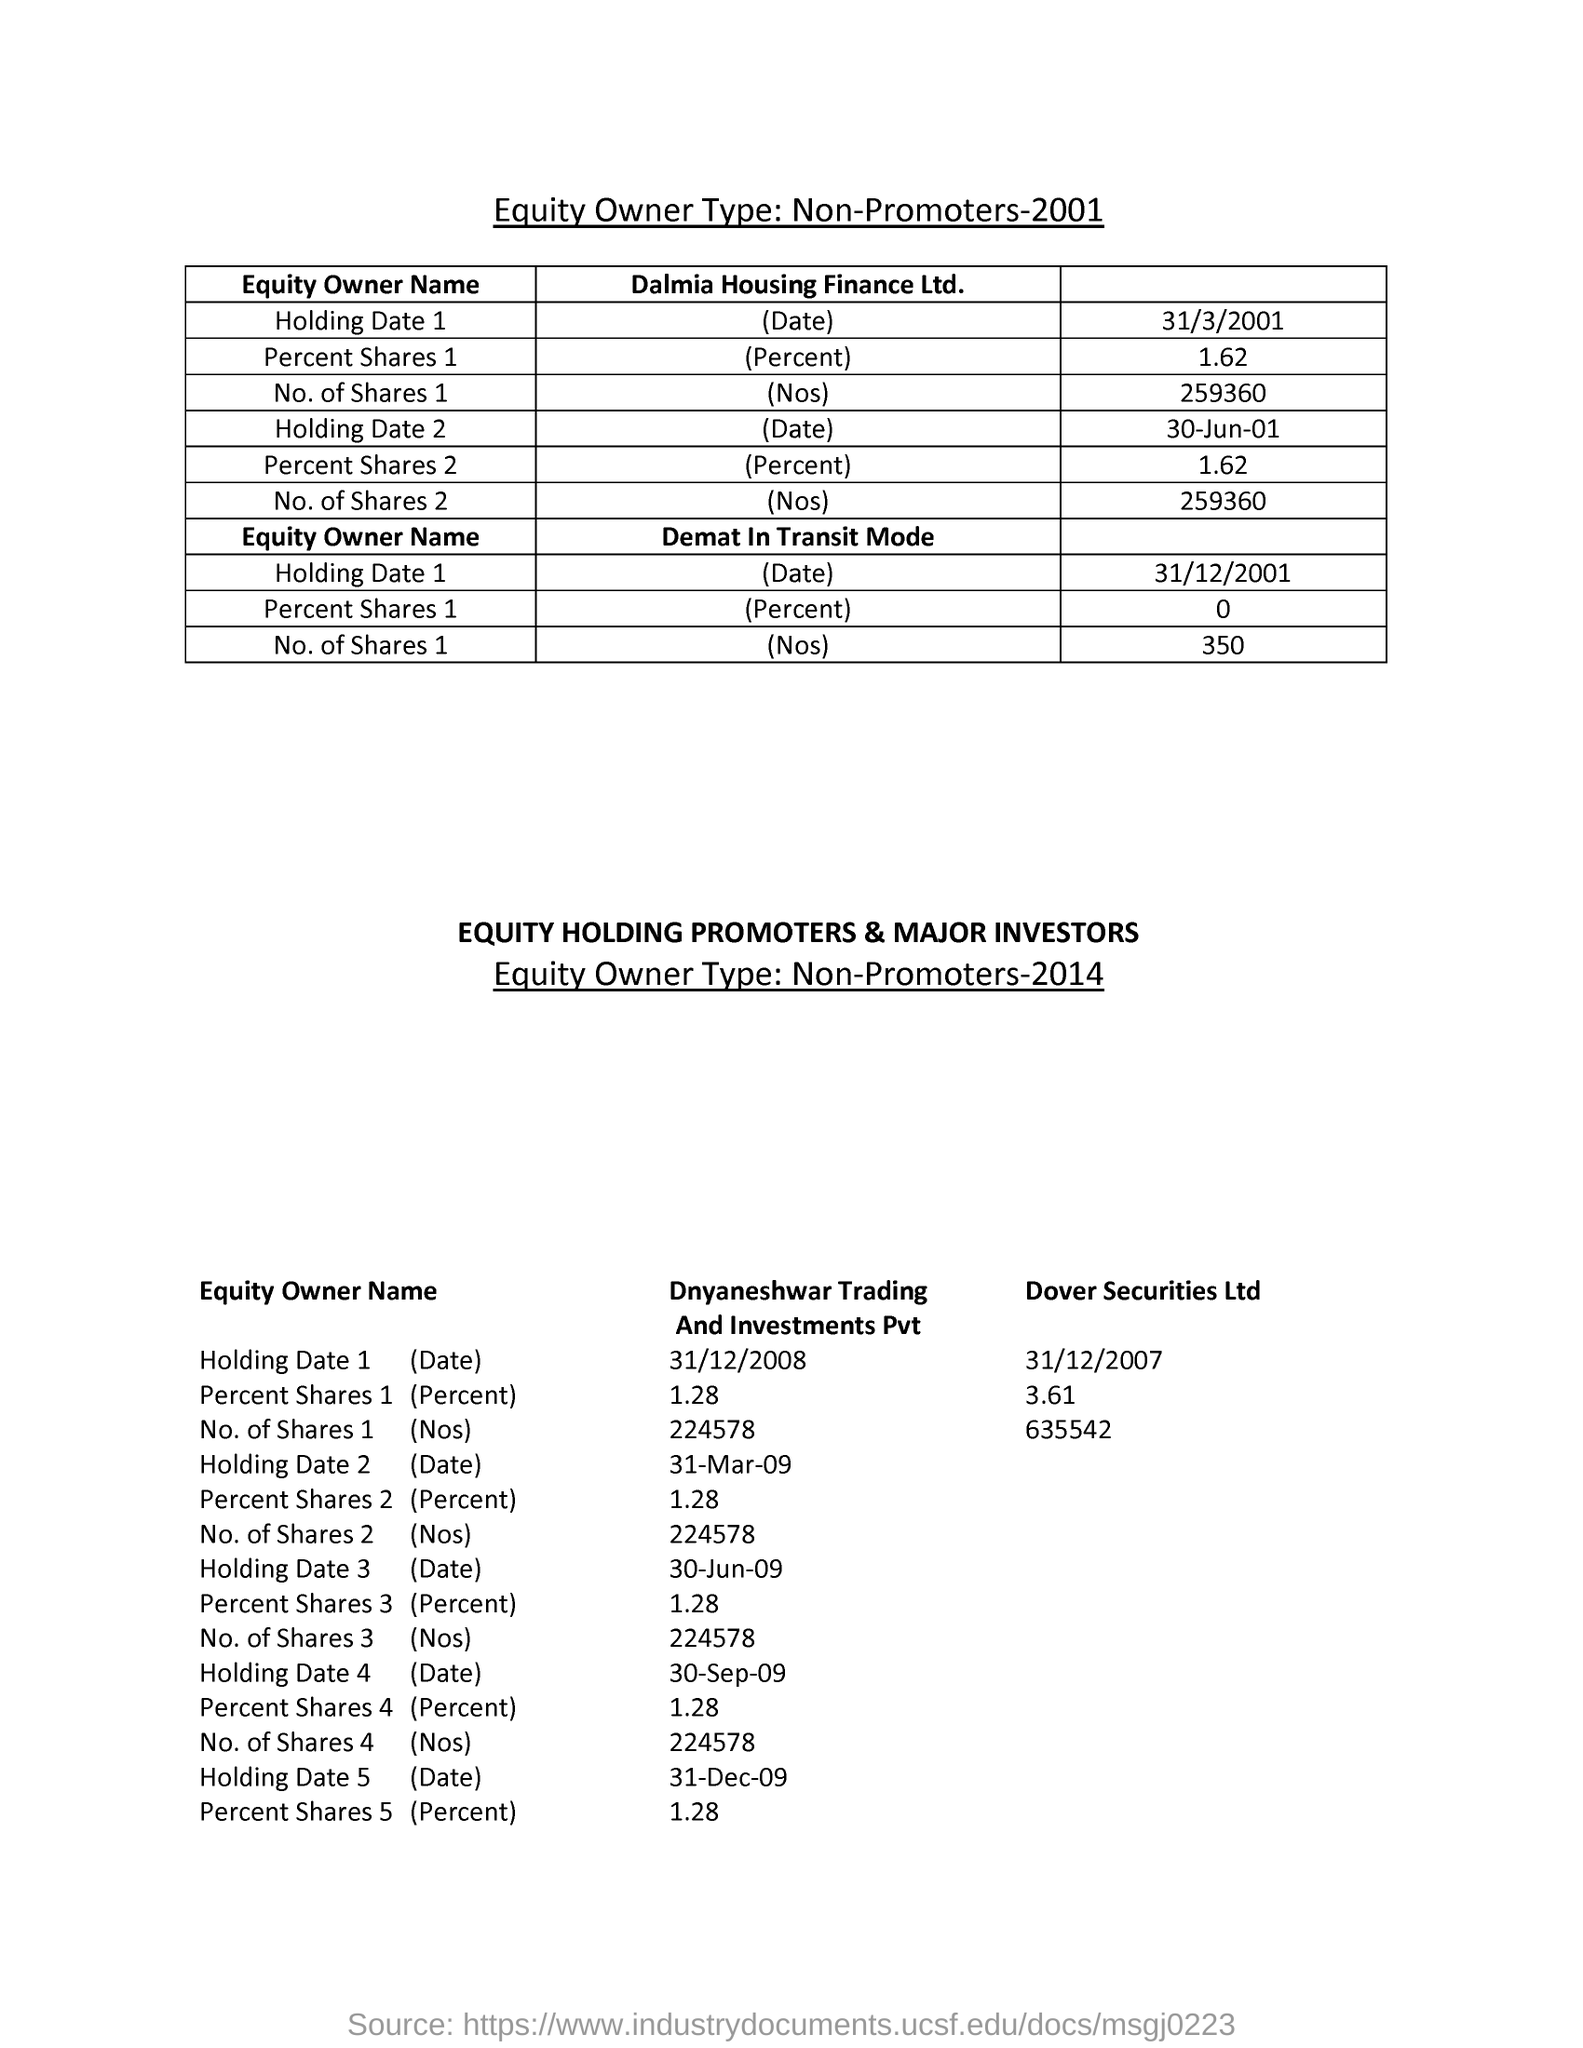Draw attention to some important aspects in this diagram. On December 31, 2007, Dover Securities Ltd held a total of 635,542 shares. On December 31, 2001, the percentage of shares held in dematerialized (demat) form in transit mode was 0%. On December 31, 2007, Dover Securities Ltd held 3.61% of the shares outstanding. 